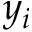<formula> <loc_0><loc_0><loc_500><loc_500>y _ { i }</formula> 